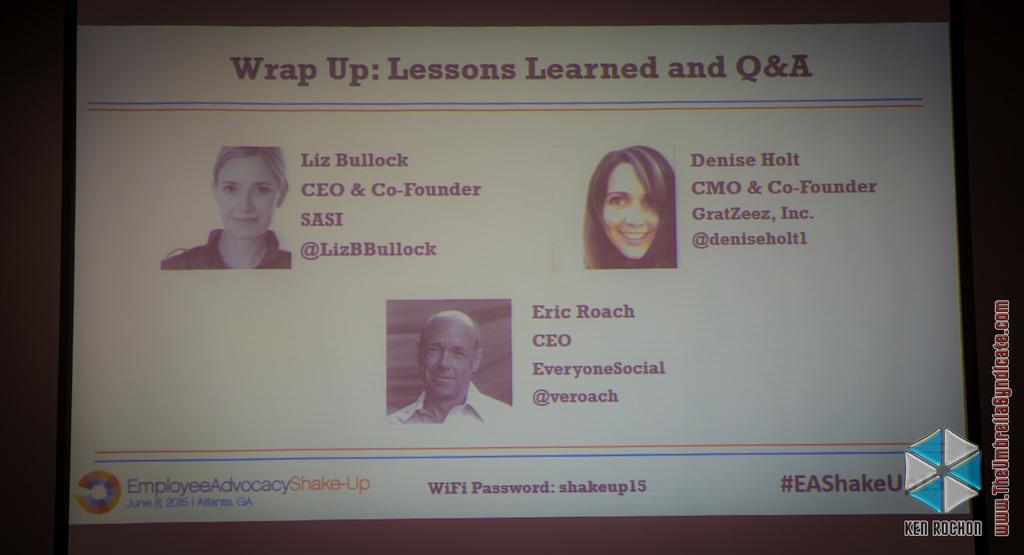What is the main object in the image? There is a screen in the image. What can be seen on the screen? The screen displays pictures of three people. Is there any text visible on the screen? Yes, there is text visible on the screen. Can you see a ghost interacting with the people on the screen? No, there is no ghost present in the image. Is the father of the three people visible on the screen? The provided facts do not mention the relationship between the people on the screen, so we cannot determine if the father is visible. 